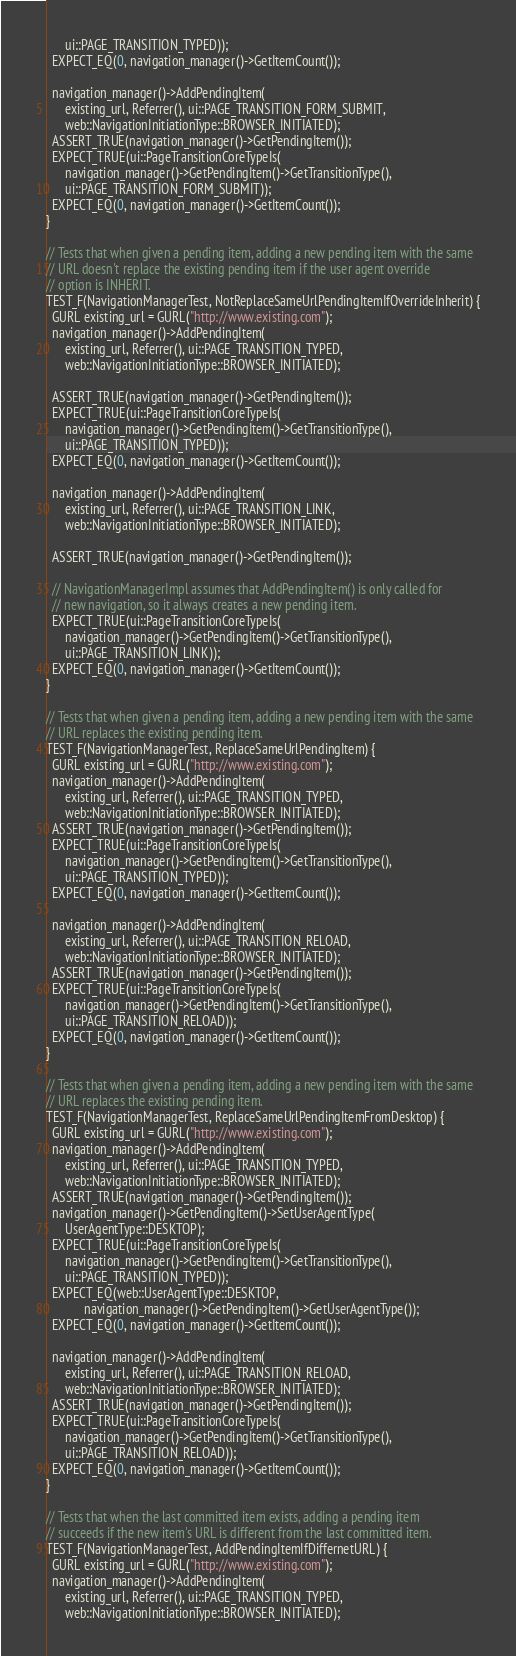<code> <loc_0><loc_0><loc_500><loc_500><_ObjectiveC_>      ui::PAGE_TRANSITION_TYPED));
  EXPECT_EQ(0, navigation_manager()->GetItemCount());

  navigation_manager()->AddPendingItem(
      existing_url, Referrer(), ui::PAGE_TRANSITION_FORM_SUBMIT,
      web::NavigationInitiationType::BROWSER_INITIATED);
  ASSERT_TRUE(navigation_manager()->GetPendingItem());
  EXPECT_TRUE(ui::PageTransitionCoreTypeIs(
      navigation_manager()->GetPendingItem()->GetTransitionType(),
      ui::PAGE_TRANSITION_FORM_SUBMIT));
  EXPECT_EQ(0, navigation_manager()->GetItemCount());
}

// Tests that when given a pending item, adding a new pending item with the same
// URL doesn't replace the existing pending item if the user agent override
// option is INHERIT.
TEST_F(NavigationManagerTest, NotReplaceSameUrlPendingItemIfOverrideInherit) {
  GURL existing_url = GURL("http://www.existing.com");
  navigation_manager()->AddPendingItem(
      existing_url, Referrer(), ui::PAGE_TRANSITION_TYPED,
      web::NavigationInitiationType::BROWSER_INITIATED);

  ASSERT_TRUE(navigation_manager()->GetPendingItem());
  EXPECT_TRUE(ui::PageTransitionCoreTypeIs(
      navigation_manager()->GetPendingItem()->GetTransitionType(),
      ui::PAGE_TRANSITION_TYPED));
  EXPECT_EQ(0, navigation_manager()->GetItemCount());

  navigation_manager()->AddPendingItem(
      existing_url, Referrer(), ui::PAGE_TRANSITION_LINK,
      web::NavigationInitiationType::BROWSER_INITIATED);

  ASSERT_TRUE(navigation_manager()->GetPendingItem());

  // NavigationManagerImpl assumes that AddPendingItem() is only called for
  // new navigation, so it always creates a new pending item.
  EXPECT_TRUE(ui::PageTransitionCoreTypeIs(
      navigation_manager()->GetPendingItem()->GetTransitionType(),
      ui::PAGE_TRANSITION_LINK));
  EXPECT_EQ(0, navigation_manager()->GetItemCount());
}

// Tests that when given a pending item, adding a new pending item with the same
// URL replaces the existing pending item.
TEST_F(NavigationManagerTest, ReplaceSameUrlPendingItem) {
  GURL existing_url = GURL("http://www.existing.com");
  navigation_manager()->AddPendingItem(
      existing_url, Referrer(), ui::PAGE_TRANSITION_TYPED,
      web::NavigationInitiationType::BROWSER_INITIATED);
  ASSERT_TRUE(navigation_manager()->GetPendingItem());
  EXPECT_TRUE(ui::PageTransitionCoreTypeIs(
      navigation_manager()->GetPendingItem()->GetTransitionType(),
      ui::PAGE_TRANSITION_TYPED));
  EXPECT_EQ(0, navigation_manager()->GetItemCount());

  navigation_manager()->AddPendingItem(
      existing_url, Referrer(), ui::PAGE_TRANSITION_RELOAD,
      web::NavigationInitiationType::BROWSER_INITIATED);
  ASSERT_TRUE(navigation_manager()->GetPendingItem());
  EXPECT_TRUE(ui::PageTransitionCoreTypeIs(
      navigation_manager()->GetPendingItem()->GetTransitionType(),
      ui::PAGE_TRANSITION_RELOAD));
  EXPECT_EQ(0, navigation_manager()->GetItemCount());
}

// Tests that when given a pending item, adding a new pending item with the same
// URL replaces the existing pending item.
TEST_F(NavigationManagerTest, ReplaceSameUrlPendingItemFromDesktop) {
  GURL existing_url = GURL("http://www.existing.com");
  navigation_manager()->AddPendingItem(
      existing_url, Referrer(), ui::PAGE_TRANSITION_TYPED,
      web::NavigationInitiationType::BROWSER_INITIATED);
  ASSERT_TRUE(navigation_manager()->GetPendingItem());
  navigation_manager()->GetPendingItem()->SetUserAgentType(
      UserAgentType::DESKTOP);
  EXPECT_TRUE(ui::PageTransitionCoreTypeIs(
      navigation_manager()->GetPendingItem()->GetTransitionType(),
      ui::PAGE_TRANSITION_TYPED));
  EXPECT_EQ(web::UserAgentType::DESKTOP,
            navigation_manager()->GetPendingItem()->GetUserAgentType());
  EXPECT_EQ(0, navigation_manager()->GetItemCount());

  navigation_manager()->AddPendingItem(
      existing_url, Referrer(), ui::PAGE_TRANSITION_RELOAD,
      web::NavigationInitiationType::BROWSER_INITIATED);
  ASSERT_TRUE(navigation_manager()->GetPendingItem());
  EXPECT_TRUE(ui::PageTransitionCoreTypeIs(
      navigation_manager()->GetPendingItem()->GetTransitionType(),
      ui::PAGE_TRANSITION_RELOAD));
  EXPECT_EQ(0, navigation_manager()->GetItemCount());
}

// Tests that when the last committed item exists, adding a pending item
// succeeds if the new item's URL is different from the last committed item.
TEST_F(NavigationManagerTest, AddPendingItemIfDiffernetURL) {
  GURL existing_url = GURL("http://www.existing.com");
  navigation_manager()->AddPendingItem(
      existing_url, Referrer(), ui::PAGE_TRANSITION_TYPED,
      web::NavigationInitiationType::BROWSER_INITIATED);
</code> 